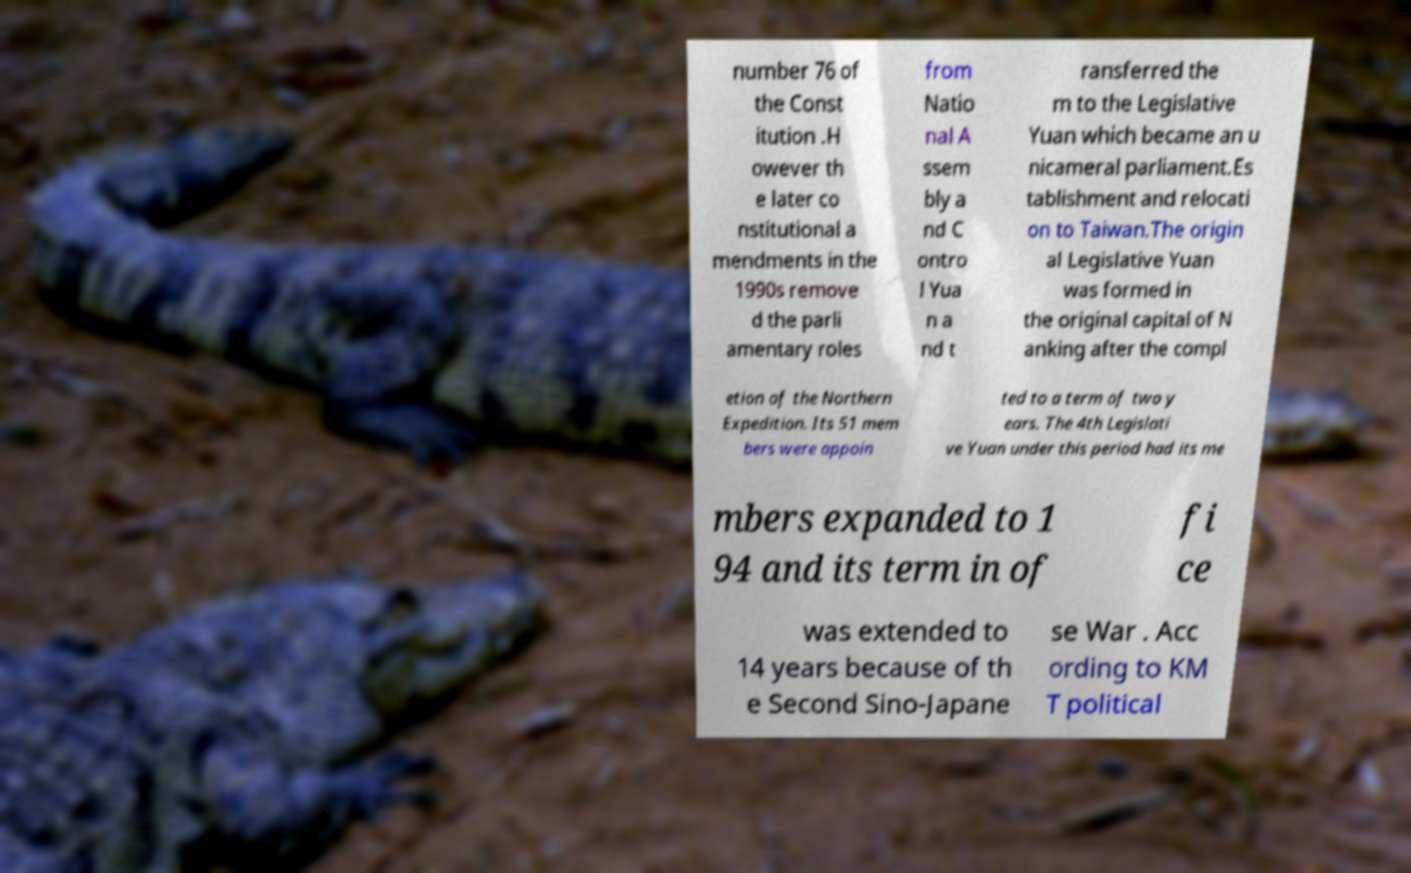Could you assist in decoding the text presented in this image and type it out clearly? number 76 of the Const itution .H owever th e later co nstitutional a mendments in the 1990s remove d the parli amentary roles from Natio nal A ssem bly a nd C ontro l Yua n a nd t ransferred the m to the Legislative Yuan which became an u nicameral parliament.Es tablishment and relocati on to Taiwan.The origin al Legislative Yuan was formed in the original capital of N anking after the compl etion of the Northern Expedition. Its 51 mem bers were appoin ted to a term of two y ears. The 4th Legislati ve Yuan under this period had its me mbers expanded to 1 94 and its term in of fi ce was extended to 14 years because of th e Second Sino-Japane se War . Acc ording to KM T political 